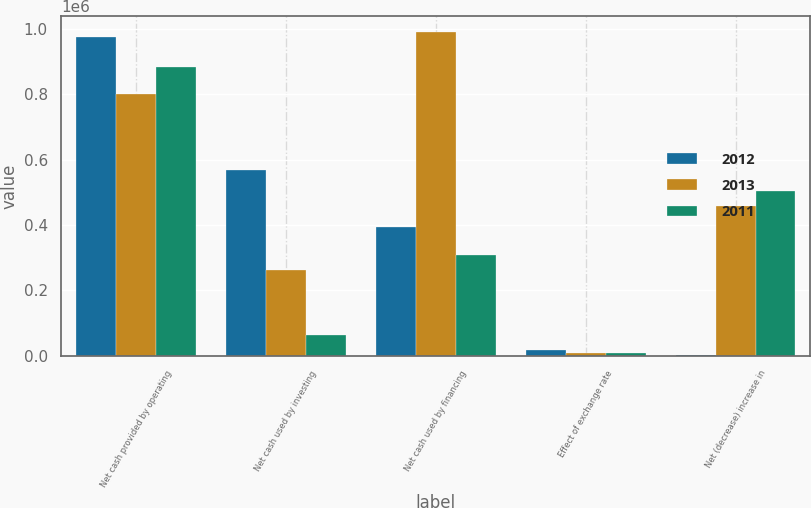Convert chart to OTSL. <chart><loc_0><loc_0><loc_500><loc_500><stacked_bar_chart><ecel><fcel>Net cash provided by operating<fcel>Net cash used by investing<fcel>Net cash used by financing<fcel>Effect of exchange rate<fcel>Net (decrease) increase in<nl><fcel>2012<fcel>977093<fcel>568867<fcel>393209<fcel>16543<fcel>1526<nl><fcel>2013<fcel>801458<fcel>261311<fcel>990073<fcel>8886<fcel>458812<nl><fcel>2011<fcel>885291<fcel>63542<fcel>308944<fcel>7788<fcel>505017<nl></chart> 